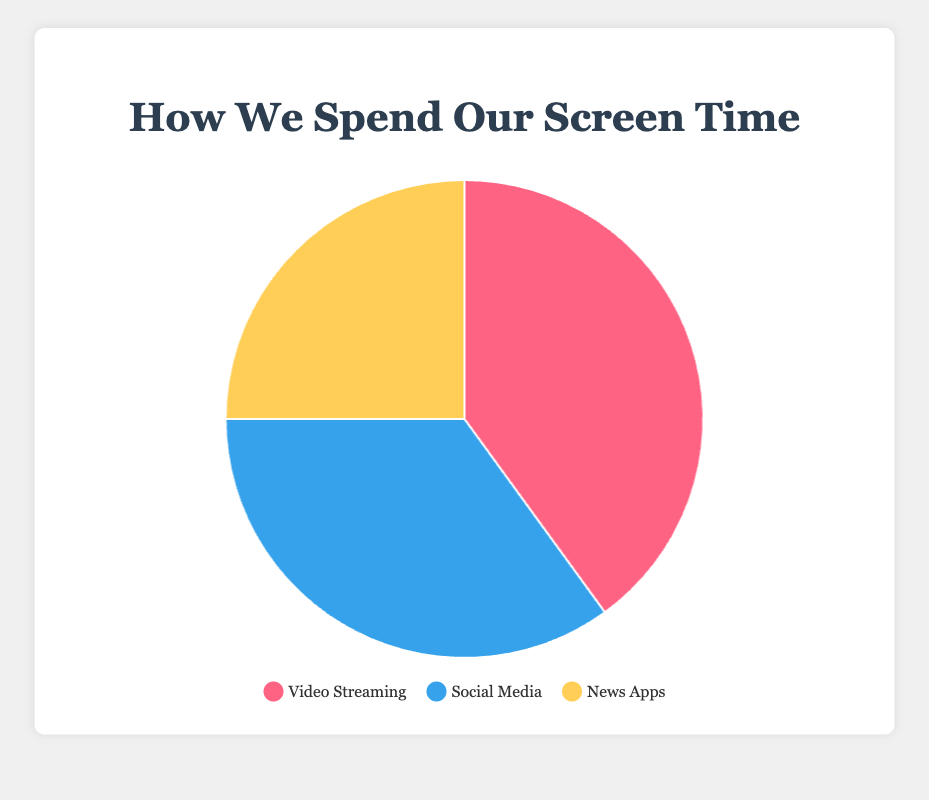What is the largest category of daily screen time? The categories listed are Video Streaming, Social Media, and News Apps, with their percentages being 40%, 35%, and 25% respectively. The largest category is the one with the highest percentage.
Answer: Video Streaming Which category has the least amount of daily screen time? The percentages for the categories are Video Streaming at 40%, Social Media at 35%, and News Apps at 25%. The smallest value is 25%.
Answer: News Apps How much more screen time is spent on Video Streaming compared to News Apps? Video Streaming accounts for 40% and News Apps for 25%. The difference is calculated as 40% - 25%.
Answer: 15% What percentage of daily screen time is spent on activities other than Social Media? Social Media takes up 35% of daily screen time. The remaining percentage will be 100% - 35%.
Answer: 65% Is the screen time for Social Media greater than that for News Apps? Social Media accounts for 35% and News Apps for 25%. Since 35% is greater than 25%, the screen time for Social Media is indeed greater.
Answer: Yes What is the combined screen time percentage for Video Streaming and Social Media? Video Streaming is 40% and Social Media is 35%. The combined percentage is 40% + 35%.
Answer: 75% Identify which category has a blue color in the pie chart. In the pie chart, the color codes are visually represented and the categories are labeled. Social Media is marked with a blue color.
Answer: Social Media What fraction of the screen time is spent on News Apps compared to Social Media? News Apps account for 25% and Social Media for 35%. The fraction is 25/35, which can be simplified further.
Answer: 5/7 If 10 hours are spent on screens daily, how many hours are devoted to Video Streaming? Video Streaming takes up 40% of daily screen time. For a total of 10 hours, the time spent on Video Streaming is 40% of 10 hours. Calculate this by multiplying 10 by 0.40.
Answer: 4 hours How does the percentage of screen time for Social Media compare to the average percentage of the three categories? First, find the average percentage: (40% + 35% + 25%) / 3 = 100% / 3 = approximately 33.33%. Compare Social Media's 35% with 33.33%.
Answer: 35% is slightly higher than 33.33% 